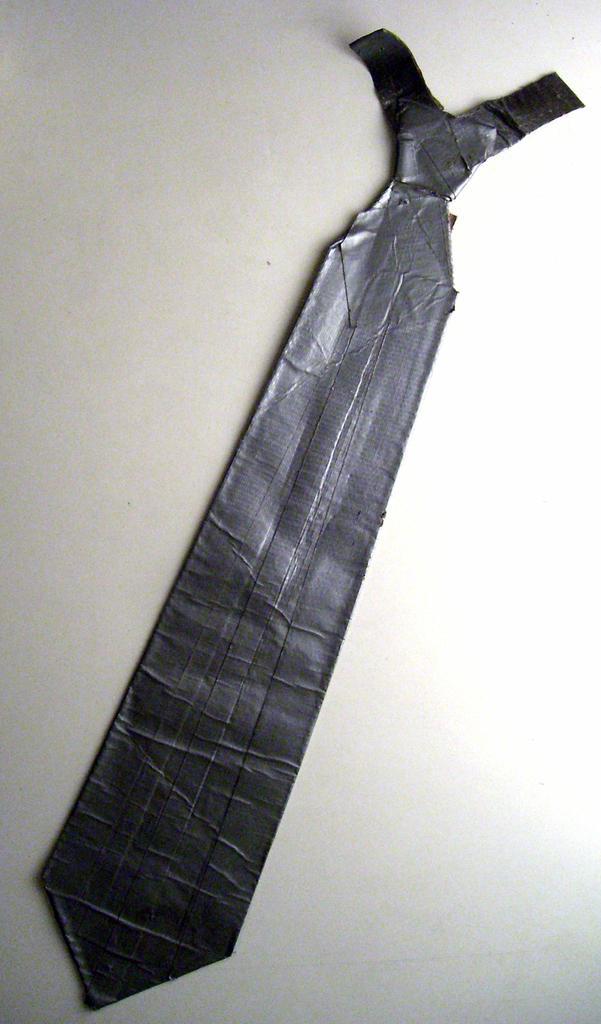In one or two sentences, can you explain what this image depicts? In the picture there is a tie placed on the floor, it is of black color. 